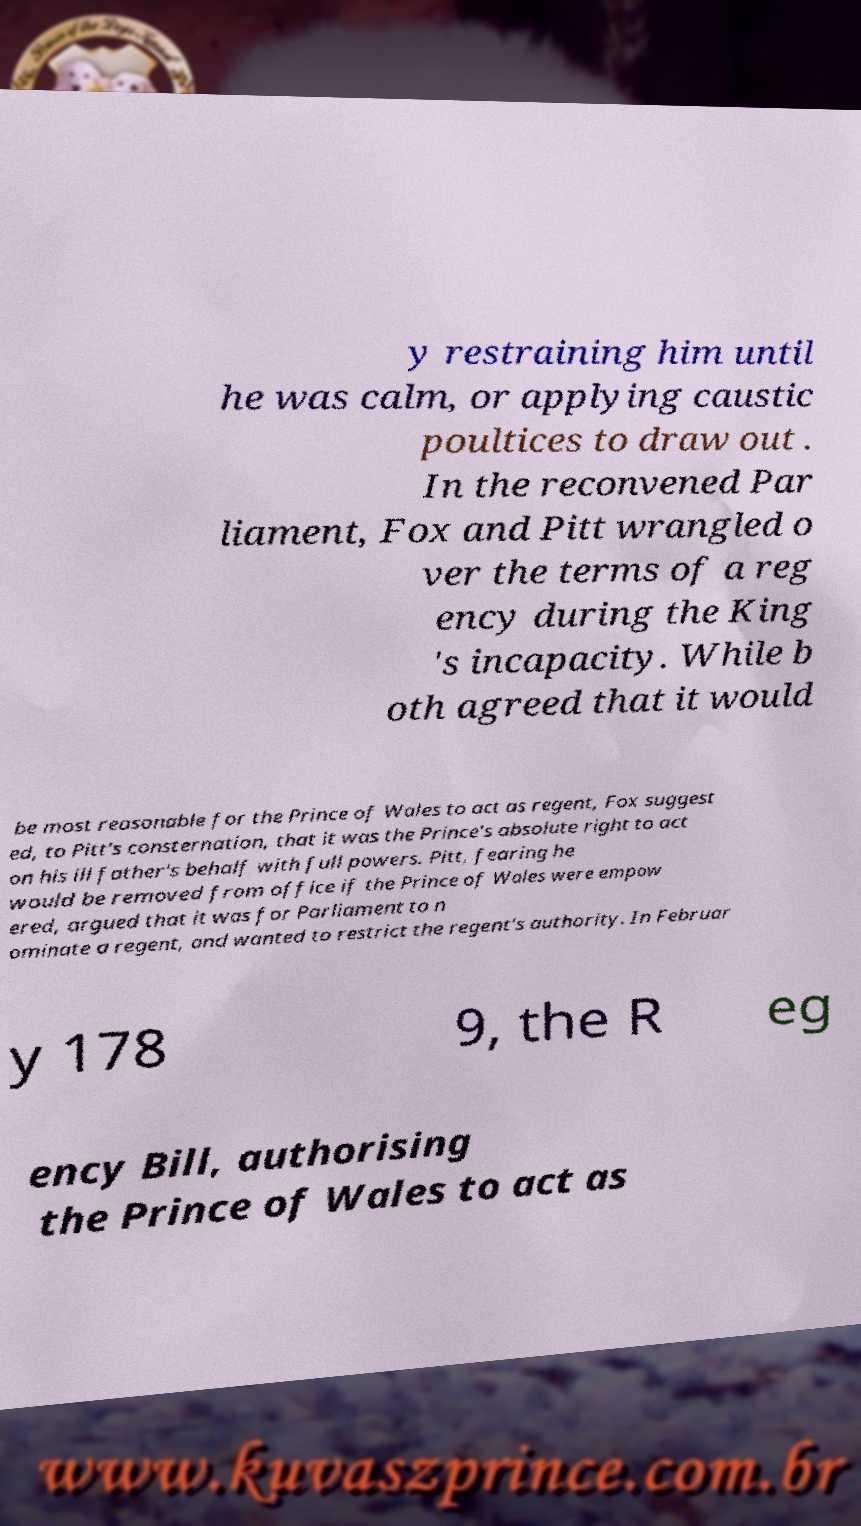Can you accurately transcribe the text from the provided image for me? y restraining him until he was calm, or applying caustic poultices to draw out . In the reconvened Par liament, Fox and Pitt wrangled o ver the terms of a reg ency during the King 's incapacity. While b oth agreed that it would be most reasonable for the Prince of Wales to act as regent, Fox suggest ed, to Pitt's consternation, that it was the Prince's absolute right to act on his ill father's behalf with full powers. Pitt, fearing he would be removed from office if the Prince of Wales were empow ered, argued that it was for Parliament to n ominate a regent, and wanted to restrict the regent's authority. In Februar y 178 9, the R eg ency Bill, authorising the Prince of Wales to act as 